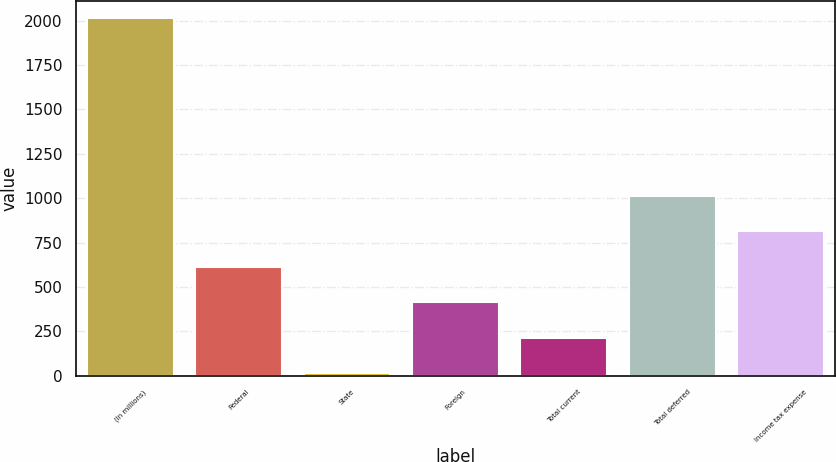<chart> <loc_0><loc_0><loc_500><loc_500><bar_chart><fcel>(In millions)<fcel>Federal<fcel>State<fcel>Foreign<fcel>Total current<fcel>Total deferred<fcel>Income tax expense<nl><fcel>2013<fcel>613.7<fcel>14<fcel>413.8<fcel>213.9<fcel>1013.5<fcel>813.6<nl></chart> 